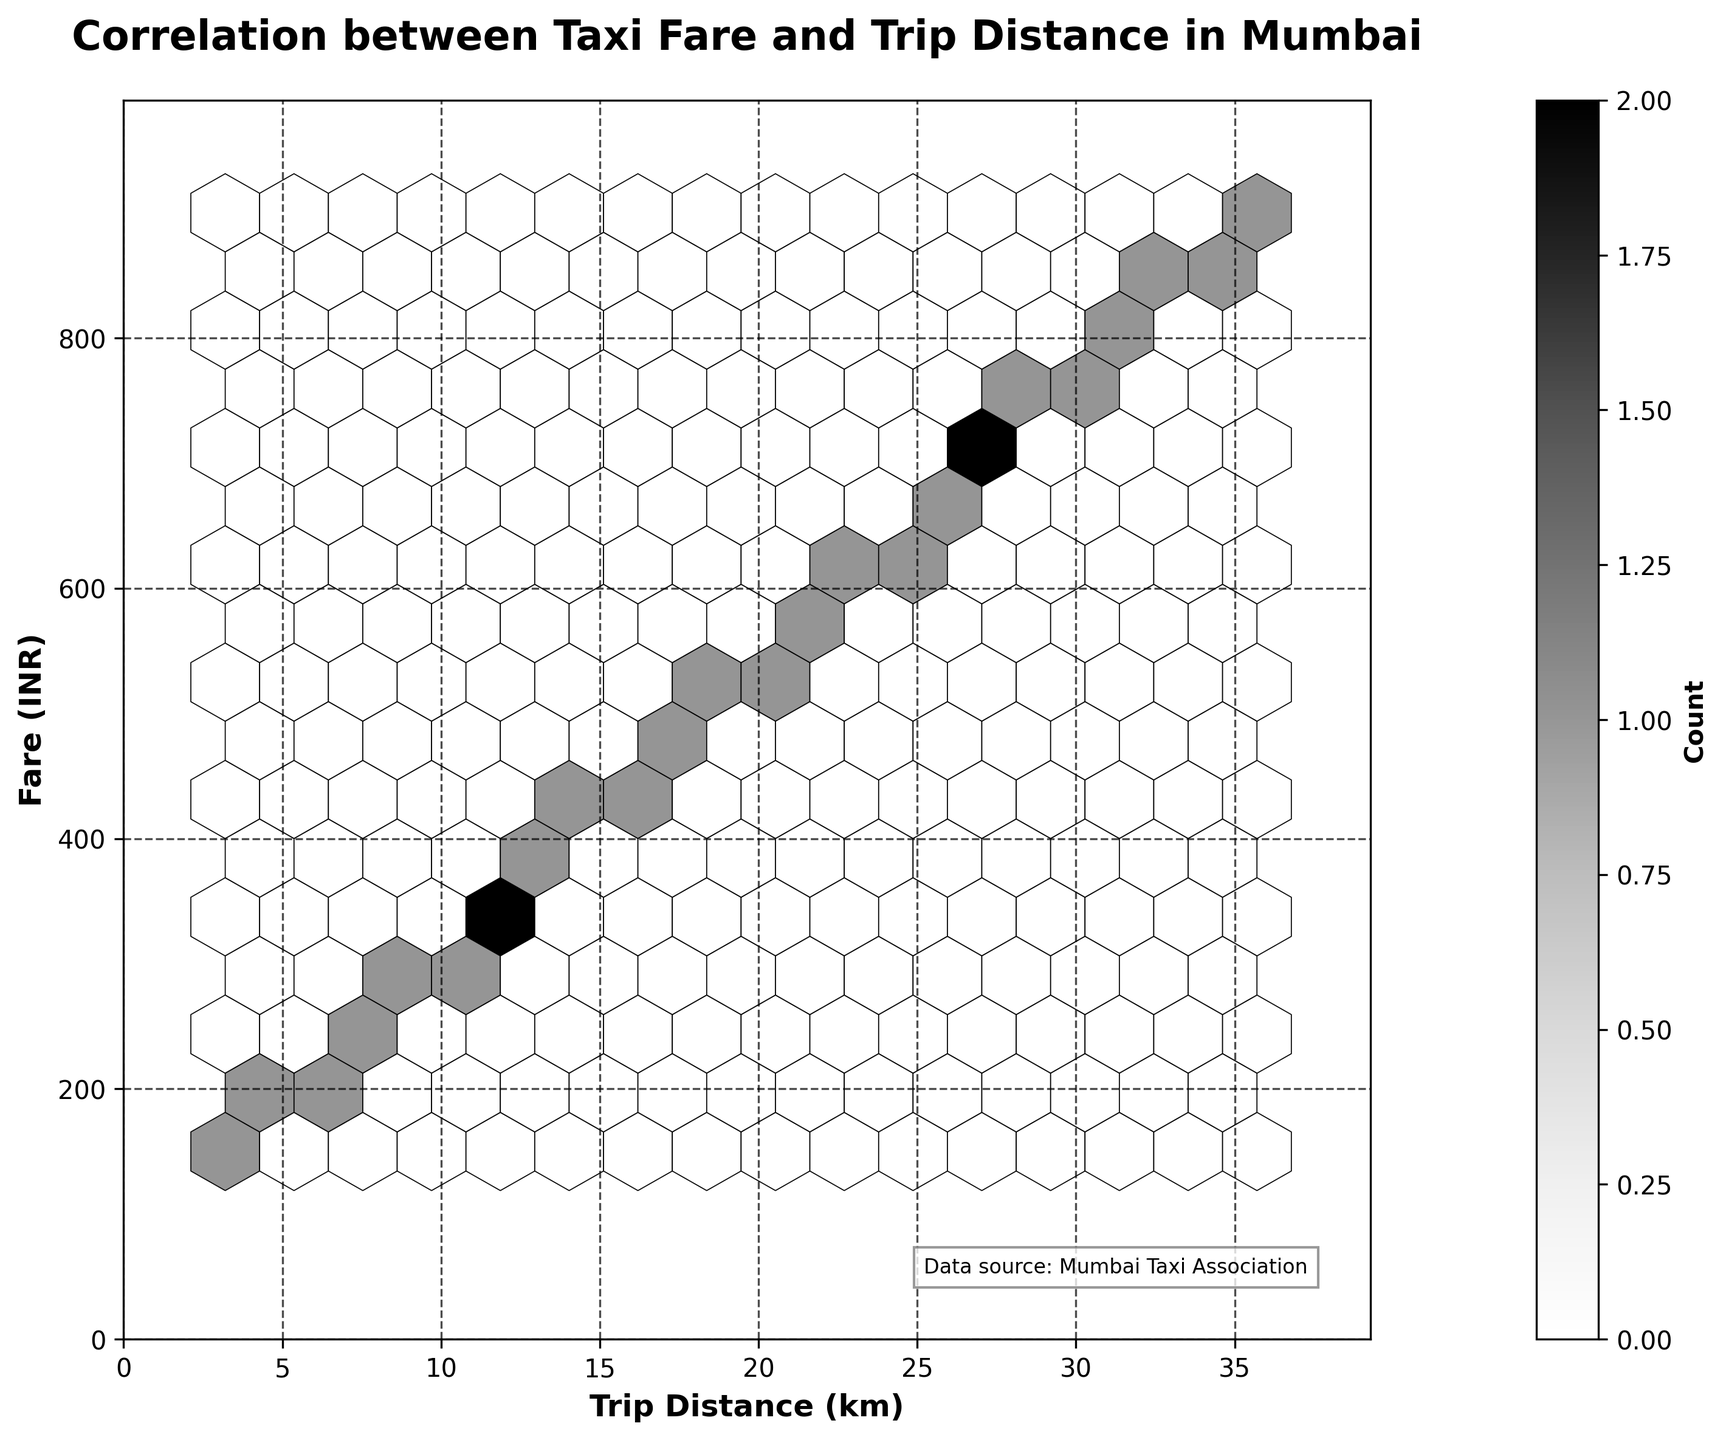What is the title of the hexbin plot? The title of the plot is located at the top of the figure. It provides a summary description of what the plot represents.
Answer: Correlation between Taxi Fare and Trip Distance in Mumbai What do the x-axis and y-axis represent in this plot? The labels on the axes tell us what each axis represents. The x-axis label stands for the trip distance in kilometers, and the y-axis label stands for the fare in Indian Rupees (INR).
Answer: The x-axis represents Trip Distance (km) and the y-axis represents Fare (INR) How is the color intensity interpreted in this hexbin plot? In a hexbin plot, color intensity represents the count of data points in each hexagon. The color bar on the side provides a clue to the intensity. Darker colors indicate a higher count of data points.
Answer: Darker colors indicate a higher count of data points What is the maximum fare shown on the y-axis? The y-axis has tick marks indicating fare values, labeled incrementally. The maximum fare can be determined by identifying the highest tick mark.
Answer: The maximum fare is around 990 INR What is the trend between taxi fare and trip distance based on the hexbin plot? To identify the trend, look at how the data points are distributed. The hexagons will likely form a linear pattern if there is a positive correlation, indicating that as the trip distance increases, the fare also increases.
Answer: There is a positive linear relationship between taxi fare and trip distance Which area in the plot has the highest concentration of data points? The highest concentration of data points is found by identifying the darkest hexagon (or group of hexagons) in the plot.
Answer: Around the midpoint, roughly between 15 to 20 km for distance and 350 to 450 INR for fare What is the average taxi fare for a trip distance of around 10 km? To approximate the average fare, look at the distribution of data points around 10 km on the x-axis and identify the typical fare on the y-axis. The hexagons' placement can help determine this.
Answer: Approximately 300 INR What can you infer about the variability in taxi fares for different trip distances? By examining the spread of the hexagons vertically for different trip distances, one can determine how consistent the fares are. Greater spread indicates higher variability.
Answer: The variability increases slightly as the distance increases, but fares are reasonably consistent Compare the fare estimates for short trips (under 10 km) versus long trips (over 30 km). To compare, look at the range of fares for trips under 10 km and then for those over 30 km. Measuring the vertical spread of hexagons in these regions gives a comparative sense.
Answer: Short trips range around 150-300 INR; long trips range from about 750 to over 900 INR, indicating a higher fare for longer distances 